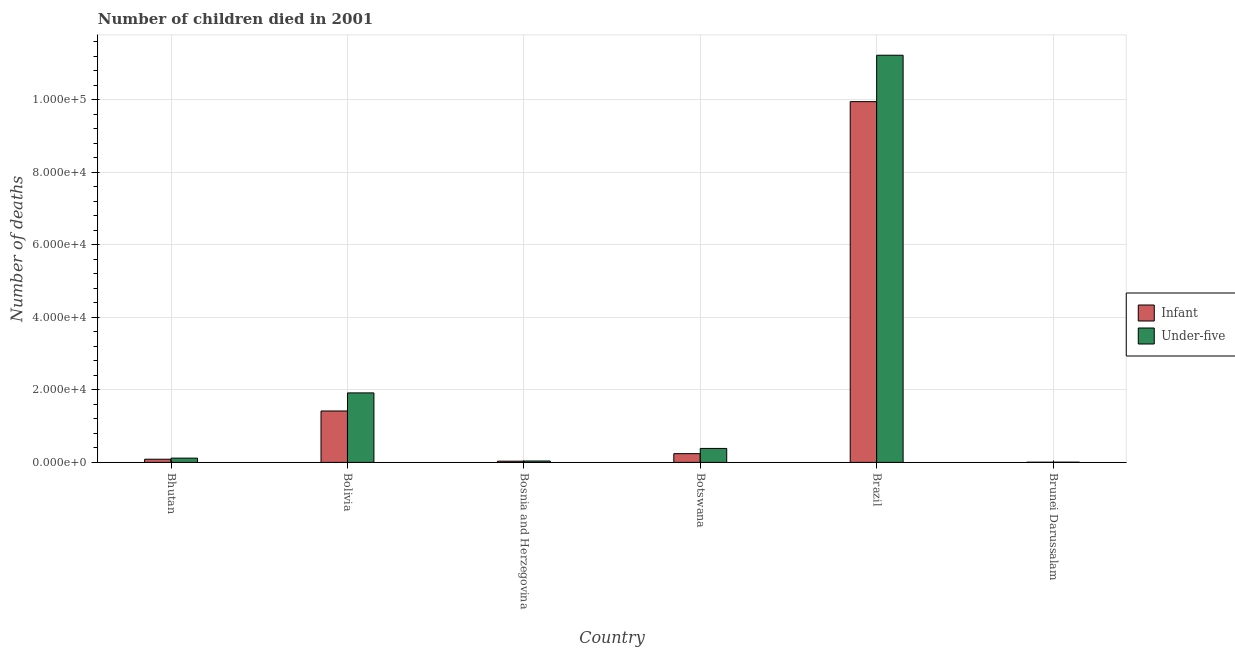How many different coloured bars are there?
Provide a short and direct response. 2. How many groups of bars are there?
Offer a very short reply. 6. Are the number of bars per tick equal to the number of legend labels?
Make the answer very short. Yes. Are the number of bars on each tick of the X-axis equal?
Your answer should be compact. Yes. How many bars are there on the 5th tick from the left?
Your answer should be very brief. 2. What is the label of the 1st group of bars from the left?
Your answer should be compact. Bhutan. In how many cases, is the number of bars for a given country not equal to the number of legend labels?
Your response must be concise. 0. What is the number of under-five deaths in Botswana?
Your answer should be compact. 3852. Across all countries, what is the maximum number of under-five deaths?
Make the answer very short. 1.12e+05. Across all countries, what is the minimum number of infant deaths?
Your answer should be compact. 49. In which country was the number of infant deaths maximum?
Ensure brevity in your answer.  Brazil. In which country was the number of under-five deaths minimum?
Your answer should be compact. Brunei Darussalam. What is the total number of under-five deaths in the graph?
Offer a very short reply. 1.37e+05. What is the difference between the number of infant deaths in Bolivia and that in Bosnia and Herzegovina?
Your answer should be compact. 1.38e+04. What is the difference between the number of under-five deaths in Botswana and the number of infant deaths in Bhutan?
Give a very brief answer. 2980. What is the average number of infant deaths per country?
Ensure brevity in your answer.  1.96e+04. What is the difference between the number of under-five deaths and number of infant deaths in Botswana?
Offer a very short reply. 1445. What is the ratio of the number of under-five deaths in Bhutan to that in Bosnia and Herzegovina?
Your answer should be compact. 3.07. Is the number of infant deaths in Botswana less than that in Brazil?
Your response must be concise. Yes. Is the difference between the number of under-five deaths in Botswana and Brazil greater than the difference between the number of infant deaths in Botswana and Brazil?
Provide a short and direct response. No. What is the difference between the highest and the second highest number of infant deaths?
Ensure brevity in your answer.  8.53e+04. What is the difference between the highest and the lowest number of under-five deaths?
Give a very brief answer. 1.12e+05. Is the sum of the number of infant deaths in Bhutan and Brazil greater than the maximum number of under-five deaths across all countries?
Offer a terse response. No. What does the 1st bar from the left in Botswana represents?
Provide a short and direct response. Infant. What does the 1st bar from the right in Botswana represents?
Ensure brevity in your answer.  Under-five. Are all the bars in the graph horizontal?
Ensure brevity in your answer.  No. Does the graph contain any zero values?
Your answer should be very brief. No. Where does the legend appear in the graph?
Provide a short and direct response. Center right. How many legend labels are there?
Offer a very short reply. 2. What is the title of the graph?
Provide a short and direct response. Number of children died in 2001. Does "Non-pregnant women" appear as one of the legend labels in the graph?
Provide a succinct answer. No. What is the label or title of the X-axis?
Your response must be concise. Country. What is the label or title of the Y-axis?
Your response must be concise. Number of deaths. What is the Number of deaths in Infant in Bhutan?
Your answer should be very brief. 872. What is the Number of deaths of Under-five in Bhutan?
Keep it short and to the point. 1175. What is the Number of deaths of Infant in Bolivia?
Offer a terse response. 1.42e+04. What is the Number of deaths in Under-five in Bolivia?
Your response must be concise. 1.92e+04. What is the Number of deaths in Infant in Bosnia and Herzegovina?
Keep it short and to the point. 335. What is the Number of deaths of Under-five in Bosnia and Herzegovina?
Your response must be concise. 383. What is the Number of deaths in Infant in Botswana?
Make the answer very short. 2407. What is the Number of deaths of Under-five in Botswana?
Keep it short and to the point. 3852. What is the Number of deaths in Infant in Brazil?
Ensure brevity in your answer.  9.95e+04. What is the Number of deaths in Under-five in Brazil?
Your response must be concise. 1.12e+05. Across all countries, what is the maximum Number of deaths of Infant?
Offer a very short reply. 9.95e+04. Across all countries, what is the maximum Number of deaths of Under-five?
Offer a very short reply. 1.12e+05. Across all countries, what is the minimum Number of deaths in Infant?
Keep it short and to the point. 49. What is the total Number of deaths of Infant in the graph?
Provide a short and direct response. 1.17e+05. What is the total Number of deaths in Under-five in the graph?
Keep it short and to the point. 1.37e+05. What is the difference between the Number of deaths of Infant in Bhutan and that in Bolivia?
Your answer should be compact. -1.33e+04. What is the difference between the Number of deaths of Under-five in Bhutan and that in Bolivia?
Offer a very short reply. -1.80e+04. What is the difference between the Number of deaths in Infant in Bhutan and that in Bosnia and Herzegovina?
Your answer should be compact. 537. What is the difference between the Number of deaths in Under-five in Bhutan and that in Bosnia and Herzegovina?
Ensure brevity in your answer.  792. What is the difference between the Number of deaths of Infant in Bhutan and that in Botswana?
Give a very brief answer. -1535. What is the difference between the Number of deaths in Under-five in Bhutan and that in Botswana?
Your answer should be very brief. -2677. What is the difference between the Number of deaths of Infant in Bhutan and that in Brazil?
Ensure brevity in your answer.  -9.86e+04. What is the difference between the Number of deaths of Under-five in Bhutan and that in Brazil?
Your answer should be compact. -1.11e+05. What is the difference between the Number of deaths of Infant in Bhutan and that in Brunei Darussalam?
Your answer should be very brief. 823. What is the difference between the Number of deaths of Under-five in Bhutan and that in Brunei Darussalam?
Give a very brief answer. 1113. What is the difference between the Number of deaths of Infant in Bolivia and that in Bosnia and Herzegovina?
Your answer should be compact. 1.38e+04. What is the difference between the Number of deaths in Under-five in Bolivia and that in Bosnia and Herzegovina?
Your response must be concise. 1.88e+04. What is the difference between the Number of deaths in Infant in Bolivia and that in Botswana?
Offer a very short reply. 1.18e+04. What is the difference between the Number of deaths in Under-five in Bolivia and that in Botswana?
Your answer should be very brief. 1.53e+04. What is the difference between the Number of deaths of Infant in Bolivia and that in Brazil?
Offer a terse response. -8.53e+04. What is the difference between the Number of deaths in Under-five in Bolivia and that in Brazil?
Ensure brevity in your answer.  -9.31e+04. What is the difference between the Number of deaths of Infant in Bolivia and that in Brunei Darussalam?
Your answer should be compact. 1.41e+04. What is the difference between the Number of deaths in Under-five in Bolivia and that in Brunei Darussalam?
Provide a short and direct response. 1.91e+04. What is the difference between the Number of deaths in Infant in Bosnia and Herzegovina and that in Botswana?
Give a very brief answer. -2072. What is the difference between the Number of deaths of Under-five in Bosnia and Herzegovina and that in Botswana?
Make the answer very short. -3469. What is the difference between the Number of deaths in Infant in Bosnia and Herzegovina and that in Brazil?
Your answer should be very brief. -9.91e+04. What is the difference between the Number of deaths of Under-five in Bosnia and Herzegovina and that in Brazil?
Provide a short and direct response. -1.12e+05. What is the difference between the Number of deaths of Infant in Bosnia and Herzegovina and that in Brunei Darussalam?
Make the answer very short. 286. What is the difference between the Number of deaths of Under-five in Bosnia and Herzegovina and that in Brunei Darussalam?
Your response must be concise. 321. What is the difference between the Number of deaths of Infant in Botswana and that in Brazil?
Provide a short and direct response. -9.71e+04. What is the difference between the Number of deaths in Under-five in Botswana and that in Brazil?
Offer a very short reply. -1.08e+05. What is the difference between the Number of deaths of Infant in Botswana and that in Brunei Darussalam?
Provide a succinct answer. 2358. What is the difference between the Number of deaths of Under-five in Botswana and that in Brunei Darussalam?
Ensure brevity in your answer.  3790. What is the difference between the Number of deaths in Infant in Brazil and that in Brunei Darussalam?
Offer a terse response. 9.94e+04. What is the difference between the Number of deaths of Under-five in Brazil and that in Brunei Darussalam?
Provide a succinct answer. 1.12e+05. What is the difference between the Number of deaths in Infant in Bhutan and the Number of deaths in Under-five in Bolivia?
Offer a terse response. -1.83e+04. What is the difference between the Number of deaths in Infant in Bhutan and the Number of deaths in Under-five in Bosnia and Herzegovina?
Ensure brevity in your answer.  489. What is the difference between the Number of deaths in Infant in Bhutan and the Number of deaths in Under-five in Botswana?
Your answer should be compact. -2980. What is the difference between the Number of deaths in Infant in Bhutan and the Number of deaths in Under-five in Brazil?
Offer a terse response. -1.11e+05. What is the difference between the Number of deaths in Infant in Bhutan and the Number of deaths in Under-five in Brunei Darussalam?
Provide a succinct answer. 810. What is the difference between the Number of deaths in Infant in Bolivia and the Number of deaths in Under-five in Bosnia and Herzegovina?
Keep it short and to the point. 1.38e+04. What is the difference between the Number of deaths in Infant in Bolivia and the Number of deaths in Under-five in Botswana?
Keep it short and to the point. 1.03e+04. What is the difference between the Number of deaths in Infant in Bolivia and the Number of deaths in Under-five in Brazil?
Make the answer very short. -9.81e+04. What is the difference between the Number of deaths of Infant in Bolivia and the Number of deaths of Under-five in Brunei Darussalam?
Offer a very short reply. 1.41e+04. What is the difference between the Number of deaths in Infant in Bosnia and Herzegovina and the Number of deaths in Under-five in Botswana?
Your response must be concise. -3517. What is the difference between the Number of deaths of Infant in Bosnia and Herzegovina and the Number of deaths of Under-five in Brazil?
Make the answer very short. -1.12e+05. What is the difference between the Number of deaths of Infant in Bosnia and Herzegovina and the Number of deaths of Under-five in Brunei Darussalam?
Provide a short and direct response. 273. What is the difference between the Number of deaths in Infant in Botswana and the Number of deaths in Under-five in Brazil?
Offer a very short reply. -1.10e+05. What is the difference between the Number of deaths of Infant in Botswana and the Number of deaths of Under-five in Brunei Darussalam?
Make the answer very short. 2345. What is the difference between the Number of deaths of Infant in Brazil and the Number of deaths of Under-five in Brunei Darussalam?
Your answer should be very brief. 9.94e+04. What is the average Number of deaths in Infant per country?
Keep it short and to the point. 1.96e+04. What is the average Number of deaths of Under-five per country?
Provide a short and direct response. 2.28e+04. What is the difference between the Number of deaths in Infant and Number of deaths in Under-five in Bhutan?
Your answer should be very brief. -303. What is the difference between the Number of deaths of Infant and Number of deaths of Under-five in Bolivia?
Ensure brevity in your answer.  -4989. What is the difference between the Number of deaths in Infant and Number of deaths in Under-five in Bosnia and Herzegovina?
Provide a succinct answer. -48. What is the difference between the Number of deaths in Infant and Number of deaths in Under-five in Botswana?
Keep it short and to the point. -1445. What is the difference between the Number of deaths of Infant and Number of deaths of Under-five in Brazil?
Offer a very short reply. -1.28e+04. What is the ratio of the Number of deaths of Infant in Bhutan to that in Bolivia?
Offer a very short reply. 0.06. What is the ratio of the Number of deaths in Under-five in Bhutan to that in Bolivia?
Offer a very short reply. 0.06. What is the ratio of the Number of deaths of Infant in Bhutan to that in Bosnia and Herzegovina?
Offer a terse response. 2.6. What is the ratio of the Number of deaths of Under-five in Bhutan to that in Bosnia and Herzegovina?
Keep it short and to the point. 3.07. What is the ratio of the Number of deaths of Infant in Bhutan to that in Botswana?
Provide a short and direct response. 0.36. What is the ratio of the Number of deaths in Under-five in Bhutan to that in Botswana?
Your answer should be compact. 0.3. What is the ratio of the Number of deaths of Infant in Bhutan to that in Brazil?
Make the answer very short. 0.01. What is the ratio of the Number of deaths in Under-five in Bhutan to that in Brazil?
Your answer should be very brief. 0.01. What is the ratio of the Number of deaths in Infant in Bhutan to that in Brunei Darussalam?
Keep it short and to the point. 17.8. What is the ratio of the Number of deaths of Under-five in Bhutan to that in Brunei Darussalam?
Keep it short and to the point. 18.95. What is the ratio of the Number of deaths of Infant in Bolivia to that in Bosnia and Herzegovina?
Offer a very short reply. 42.31. What is the ratio of the Number of deaths in Under-five in Bolivia to that in Bosnia and Herzegovina?
Your answer should be compact. 50.03. What is the ratio of the Number of deaths of Infant in Bolivia to that in Botswana?
Make the answer very short. 5.89. What is the ratio of the Number of deaths of Under-five in Bolivia to that in Botswana?
Provide a succinct answer. 4.97. What is the ratio of the Number of deaths in Infant in Bolivia to that in Brazil?
Provide a succinct answer. 0.14. What is the ratio of the Number of deaths in Under-five in Bolivia to that in Brazil?
Ensure brevity in your answer.  0.17. What is the ratio of the Number of deaths of Infant in Bolivia to that in Brunei Darussalam?
Keep it short and to the point. 289.24. What is the ratio of the Number of deaths of Under-five in Bolivia to that in Brunei Darussalam?
Provide a short and direct response. 309.06. What is the ratio of the Number of deaths in Infant in Bosnia and Herzegovina to that in Botswana?
Provide a succinct answer. 0.14. What is the ratio of the Number of deaths of Under-five in Bosnia and Herzegovina to that in Botswana?
Ensure brevity in your answer.  0.1. What is the ratio of the Number of deaths in Infant in Bosnia and Herzegovina to that in Brazil?
Provide a short and direct response. 0. What is the ratio of the Number of deaths in Under-five in Bosnia and Herzegovina to that in Brazil?
Offer a very short reply. 0. What is the ratio of the Number of deaths of Infant in Bosnia and Herzegovina to that in Brunei Darussalam?
Make the answer very short. 6.84. What is the ratio of the Number of deaths of Under-five in Bosnia and Herzegovina to that in Brunei Darussalam?
Your response must be concise. 6.18. What is the ratio of the Number of deaths of Infant in Botswana to that in Brazil?
Ensure brevity in your answer.  0.02. What is the ratio of the Number of deaths of Under-five in Botswana to that in Brazil?
Keep it short and to the point. 0.03. What is the ratio of the Number of deaths of Infant in Botswana to that in Brunei Darussalam?
Your response must be concise. 49.12. What is the ratio of the Number of deaths in Under-five in Botswana to that in Brunei Darussalam?
Offer a very short reply. 62.13. What is the ratio of the Number of deaths in Infant in Brazil to that in Brunei Darussalam?
Provide a succinct answer. 2030.24. What is the ratio of the Number of deaths in Under-five in Brazil to that in Brunei Darussalam?
Offer a terse response. 1810.89. What is the difference between the highest and the second highest Number of deaths of Infant?
Give a very brief answer. 8.53e+04. What is the difference between the highest and the second highest Number of deaths of Under-five?
Your answer should be very brief. 9.31e+04. What is the difference between the highest and the lowest Number of deaths in Infant?
Keep it short and to the point. 9.94e+04. What is the difference between the highest and the lowest Number of deaths in Under-five?
Offer a very short reply. 1.12e+05. 